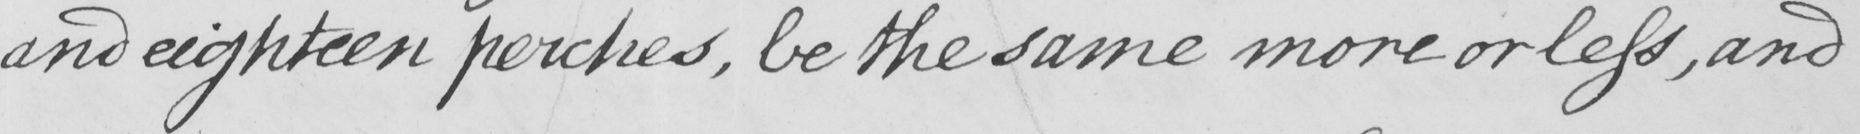Can you tell me what this handwritten text says? and eighteen perches , be the same more or less , and 